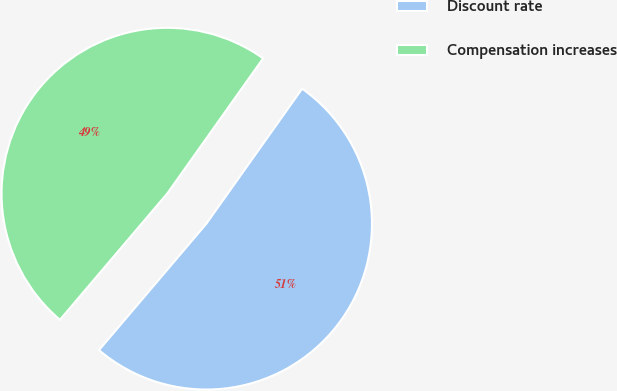Convert chart to OTSL. <chart><loc_0><loc_0><loc_500><loc_500><pie_chart><fcel>Discount rate<fcel>Compensation increases<nl><fcel>51.39%<fcel>48.61%<nl></chart> 